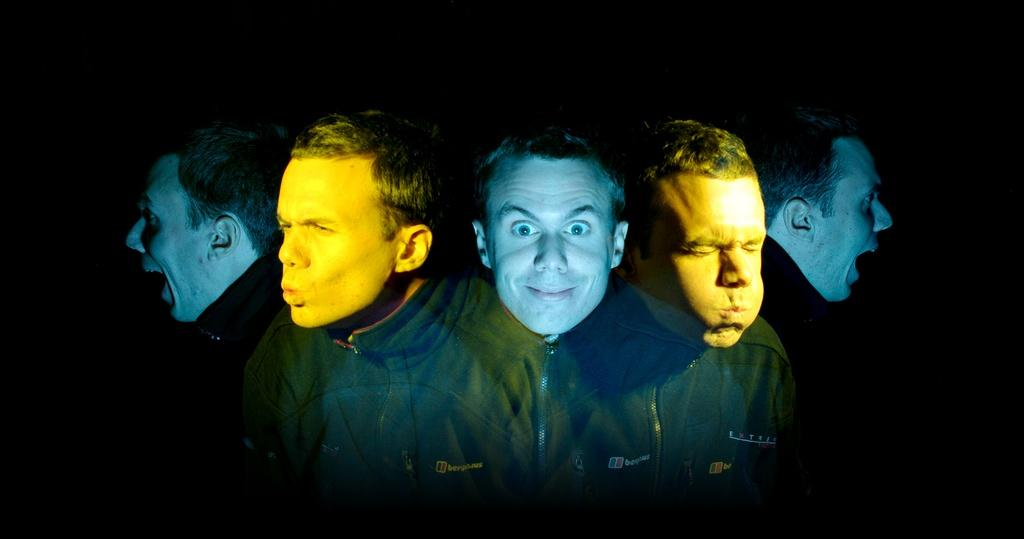What can be observed about the image? The image is edited, and there are different facial reactions of a person in the image. How many facial reactions can be seen? The number of facial reactions cannot be determined from the provided facts, but there are at least two different reactions visible. What type of letters can be seen in the image? There are no letters present in the image; it features a person with different facial reactions. Is there a rock visible in the image? There is no rock present in the image. Can you see a kitten in the image? There is no kitten present in the image. 